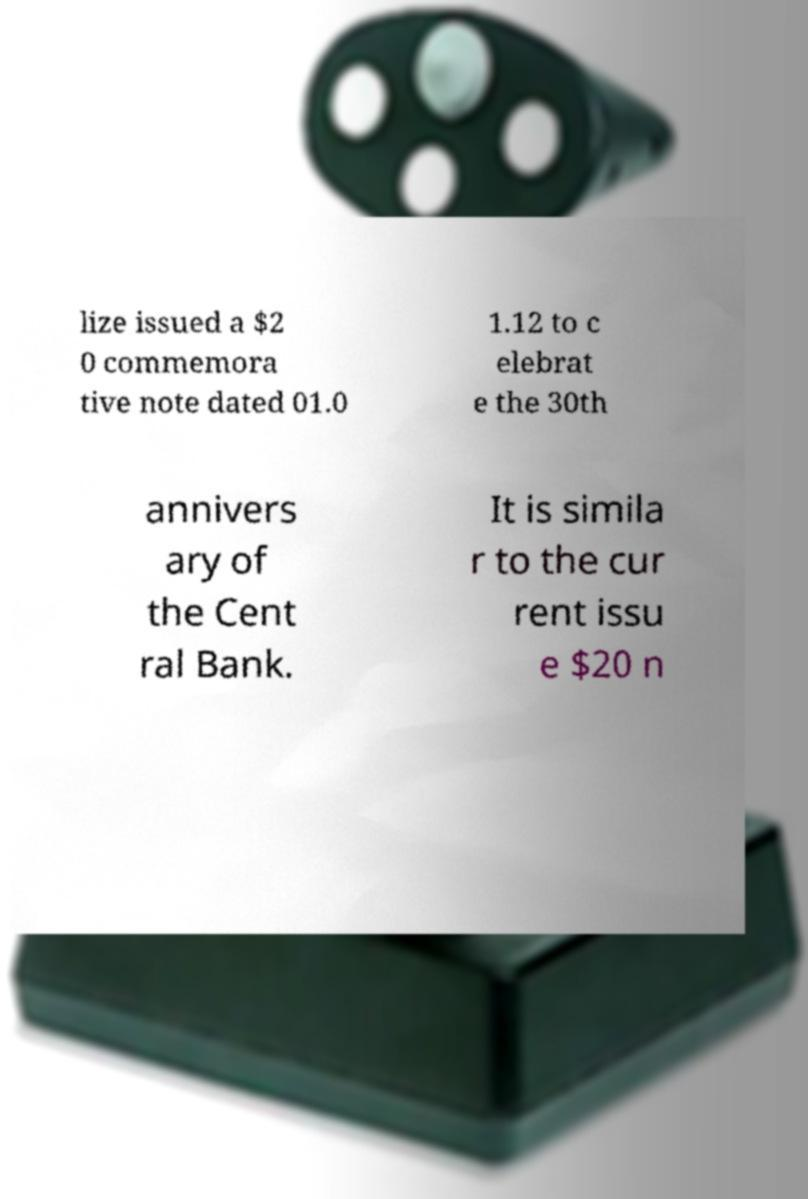Could you extract and type out the text from this image? lize issued a $2 0 commemora tive note dated 01.0 1.12 to c elebrat e the 30th annivers ary of the Cent ral Bank. It is simila r to the cur rent issu e $20 n 